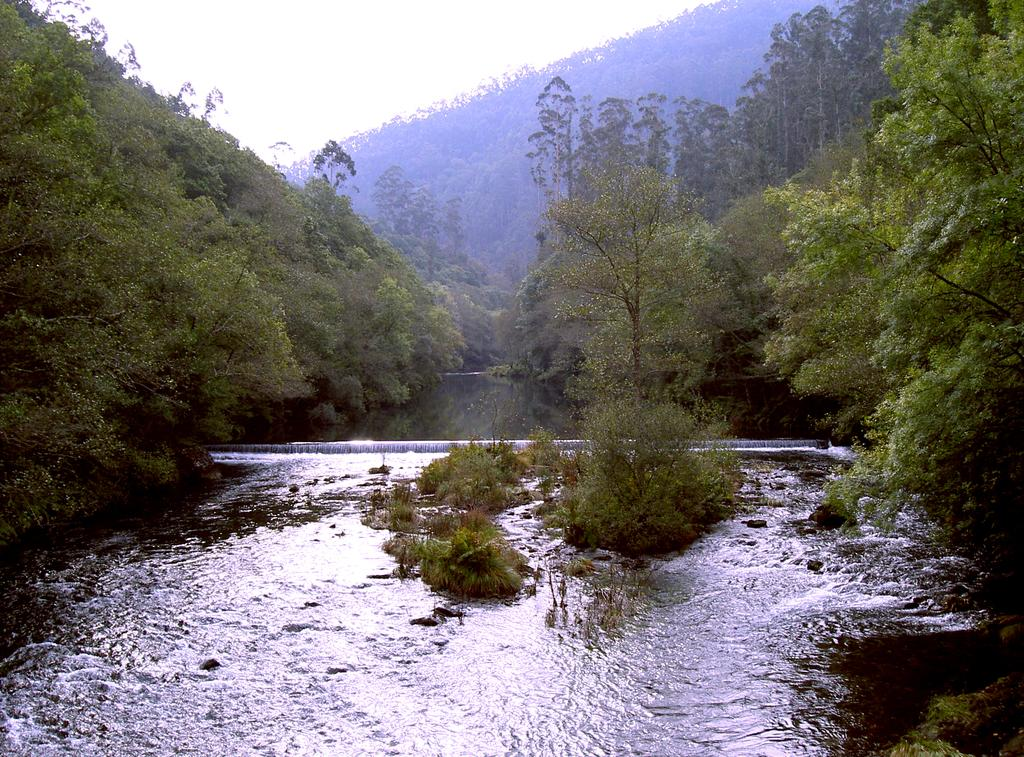What is visible in the image that is not solid? Water is visible in the image and is not solid. What type of vegetation can be seen in the image? Plants and trees are visible in the image. What is visible in the background of the image? The sky is visible in the image. What type of food is being served in the image? There is no food present in the image. What type of apparel is being worn by the plants in the image? Plants do not wear apparel, and there are no people or animals in the image. --- 